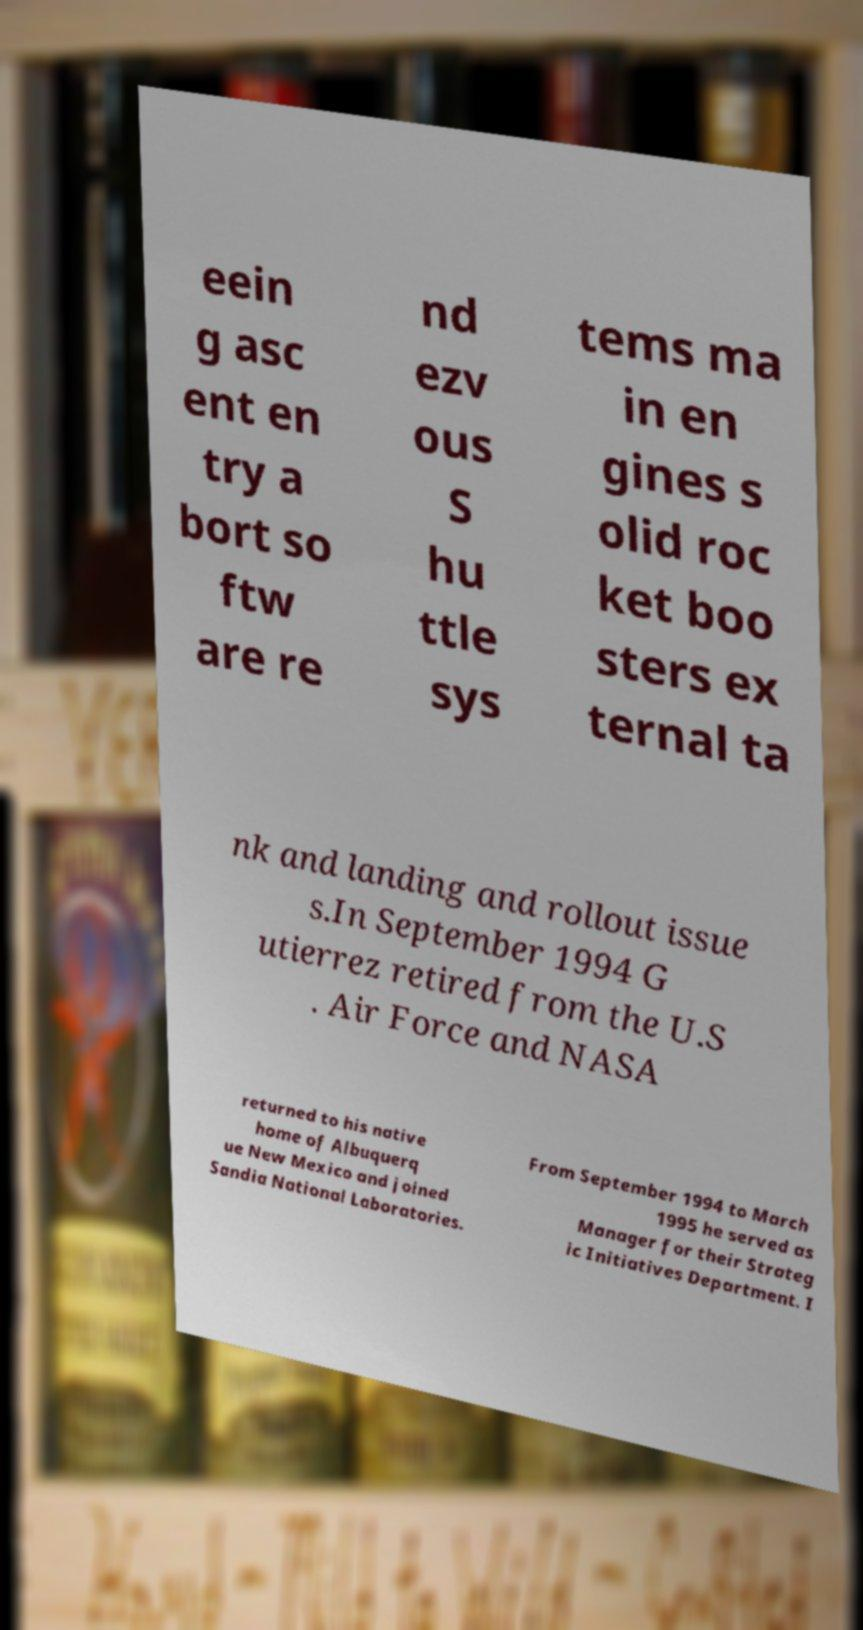For documentation purposes, I need the text within this image transcribed. Could you provide that? eein g asc ent en try a bort so ftw are re nd ezv ous S hu ttle sys tems ma in en gines s olid roc ket boo sters ex ternal ta nk and landing and rollout issue s.In September 1994 G utierrez retired from the U.S . Air Force and NASA returned to his native home of Albuquerq ue New Mexico and joined Sandia National Laboratories. From September 1994 to March 1995 he served as Manager for their Strateg ic Initiatives Department. I 